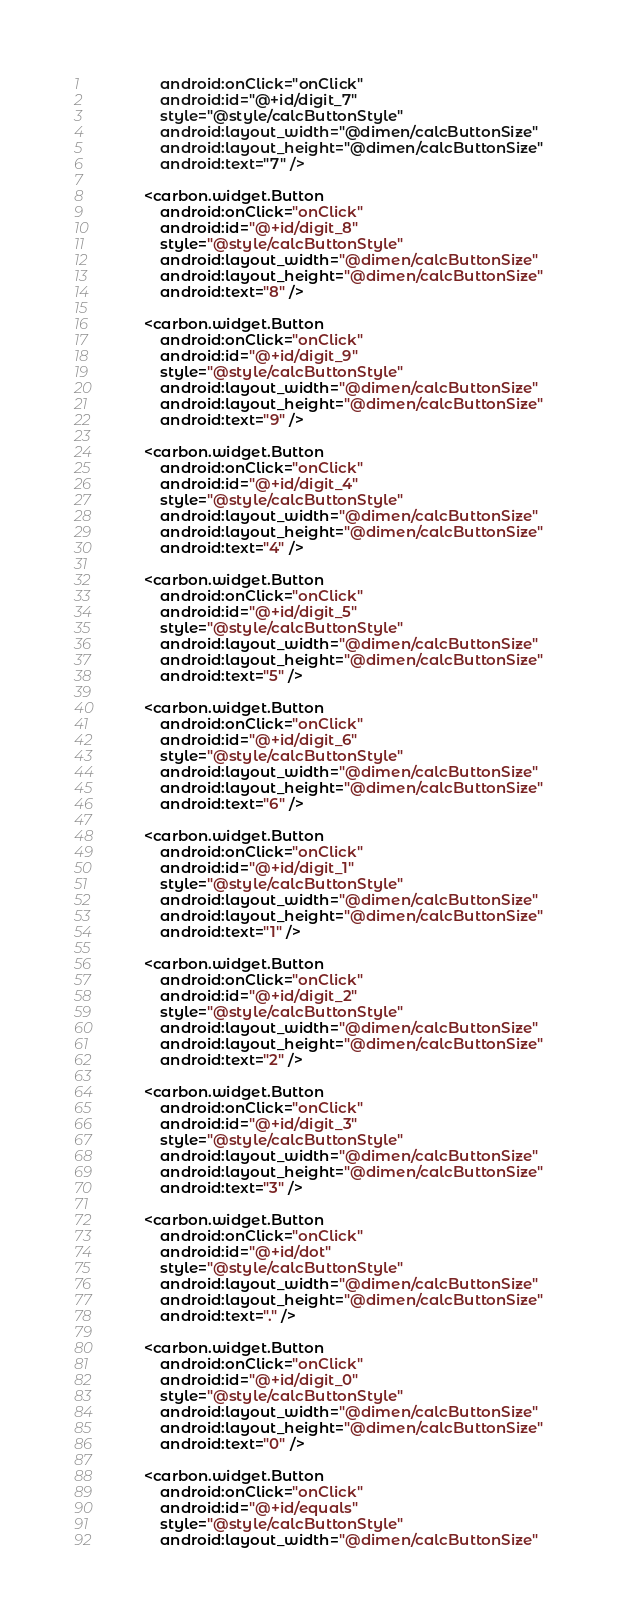Convert code to text. <code><loc_0><loc_0><loc_500><loc_500><_XML_>                android:onClick="onClick"
                android:id="@+id/digit_7"
                style="@style/calcButtonStyle"
                android:layout_width="@dimen/calcButtonSize"
                android:layout_height="@dimen/calcButtonSize"
                android:text="7" />

            <carbon.widget.Button
                android:onClick="onClick"
                android:id="@+id/digit_8"
                style="@style/calcButtonStyle"
                android:layout_width="@dimen/calcButtonSize"
                android:layout_height="@dimen/calcButtonSize"
                android:text="8" />

            <carbon.widget.Button
                android:onClick="onClick"
                android:id="@+id/digit_9"
                style="@style/calcButtonStyle"
                android:layout_width="@dimen/calcButtonSize"
                android:layout_height="@dimen/calcButtonSize"
                android:text="9" />

            <carbon.widget.Button
                android:onClick="onClick"
                android:id="@+id/digit_4"
                style="@style/calcButtonStyle"
                android:layout_width="@dimen/calcButtonSize"
                android:layout_height="@dimen/calcButtonSize"
                android:text="4" />

            <carbon.widget.Button
                android:onClick="onClick"
                android:id="@+id/digit_5"
                style="@style/calcButtonStyle"
                android:layout_width="@dimen/calcButtonSize"
                android:layout_height="@dimen/calcButtonSize"
                android:text="5" />

            <carbon.widget.Button
                android:onClick="onClick"
                android:id="@+id/digit_6"
                style="@style/calcButtonStyle"
                android:layout_width="@dimen/calcButtonSize"
                android:layout_height="@dimen/calcButtonSize"
                android:text="6" />

            <carbon.widget.Button
                android:onClick="onClick"
                android:id="@+id/digit_1"
                style="@style/calcButtonStyle"
                android:layout_width="@dimen/calcButtonSize"
                android:layout_height="@dimen/calcButtonSize"
                android:text="1" />

            <carbon.widget.Button
                android:onClick="onClick"
                android:id="@+id/digit_2"
                style="@style/calcButtonStyle"
                android:layout_width="@dimen/calcButtonSize"
                android:layout_height="@dimen/calcButtonSize"
                android:text="2" />

            <carbon.widget.Button
                android:onClick="onClick"
                android:id="@+id/digit_3"
                style="@style/calcButtonStyle"
                android:layout_width="@dimen/calcButtonSize"
                android:layout_height="@dimen/calcButtonSize"
                android:text="3" />

            <carbon.widget.Button
                android:onClick="onClick"
                android:id="@+id/dot"
                style="@style/calcButtonStyle"
                android:layout_width="@dimen/calcButtonSize"
                android:layout_height="@dimen/calcButtonSize"
                android:text="." />

            <carbon.widget.Button
                android:onClick="onClick"
                android:id="@+id/digit_0"
                style="@style/calcButtonStyle"
                android:layout_width="@dimen/calcButtonSize"
                android:layout_height="@dimen/calcButtonSize"
                android:text="0" />

            <carbon.widget.Button
                android:onClick="onClick"
                android:id="@+id/equals"
                style="@style/calcButtonStyle"
                android:layout_width="@dimen/calcButtonSize"</code> 